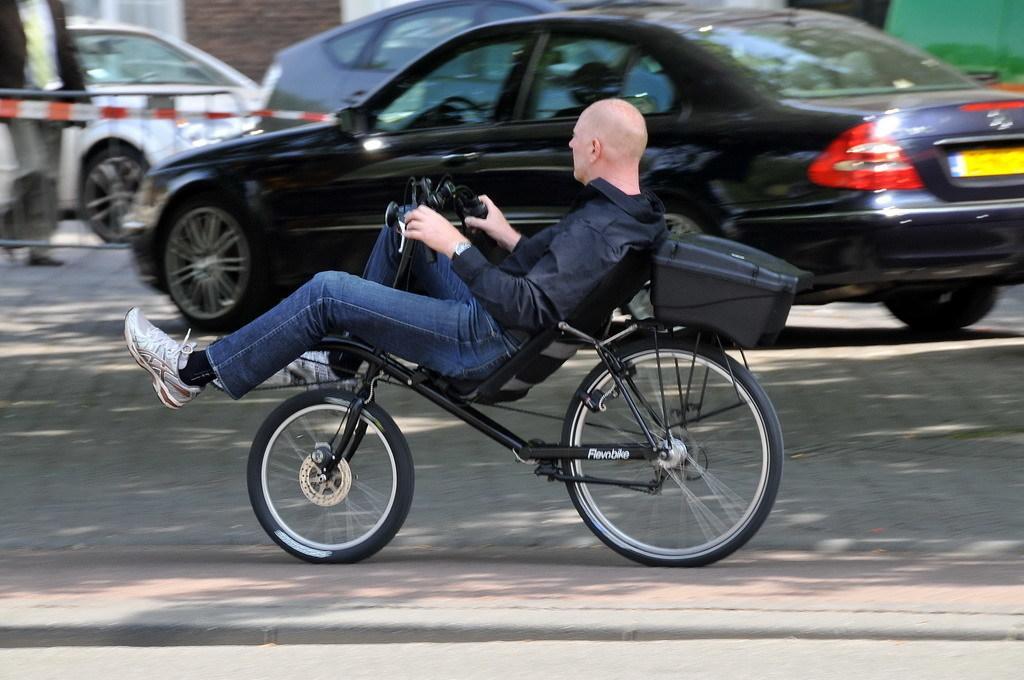How would you summarize this image in a sentence or two? In this image, human is riding a bicycle on the road. And the background, few vehicles are parked. On left side corner, we can see barricade. A human is walking near the barricade. A brick wall we can see here. And white color here, here. And here we can see green color. 